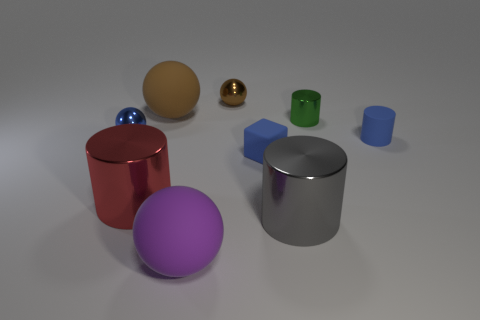Subtract 1 cylinders. How many cylinders are left? 3 Add 1 large matte objects. How many objects exist? 10 Subtract all green spheres. Subtract all brown blocks. How many spheres are left? 4 Subtract all balls. How many objects are left? 5 Subtract 0 yellow cylinders. How many objects are left? 9 Subtract all large blue shiny things. Subtract all small blue shiny spheres. How many objects are left? 8 Add 2 tiny spheres. How many tiny spheres are left? 4 Add 4 big purple spheres. How many big purple spheres exist? 5 